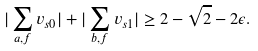Convert formula to latex. <formula><loc_0><loc_0><loc_500><loc_500>| \sum _ { a , f } v _ { s 0 } | + | \sum _ { b , f } v _ { s 1 } | \geq 2 - \sqrt { 2 } - 2 \epsilon .</formula> 